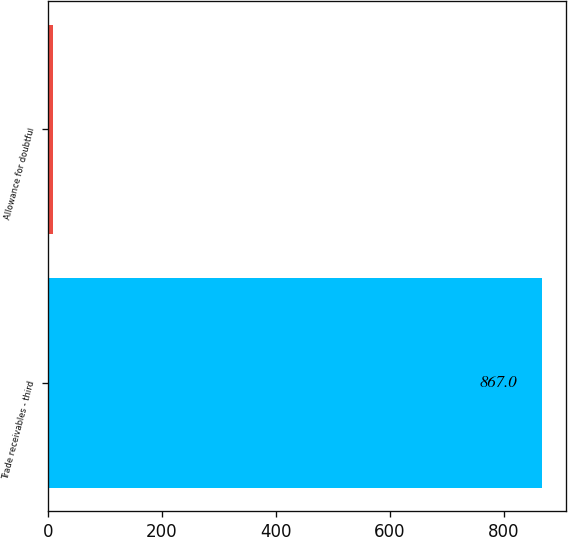Convert chart. <chart><loc_0><loc_0><loc_500><loc_500><bar_chart><fcel>Trade receivables - third<fcel>Allowance for doubtful<nl><fcel>867<fcel>9<nl></chart> 